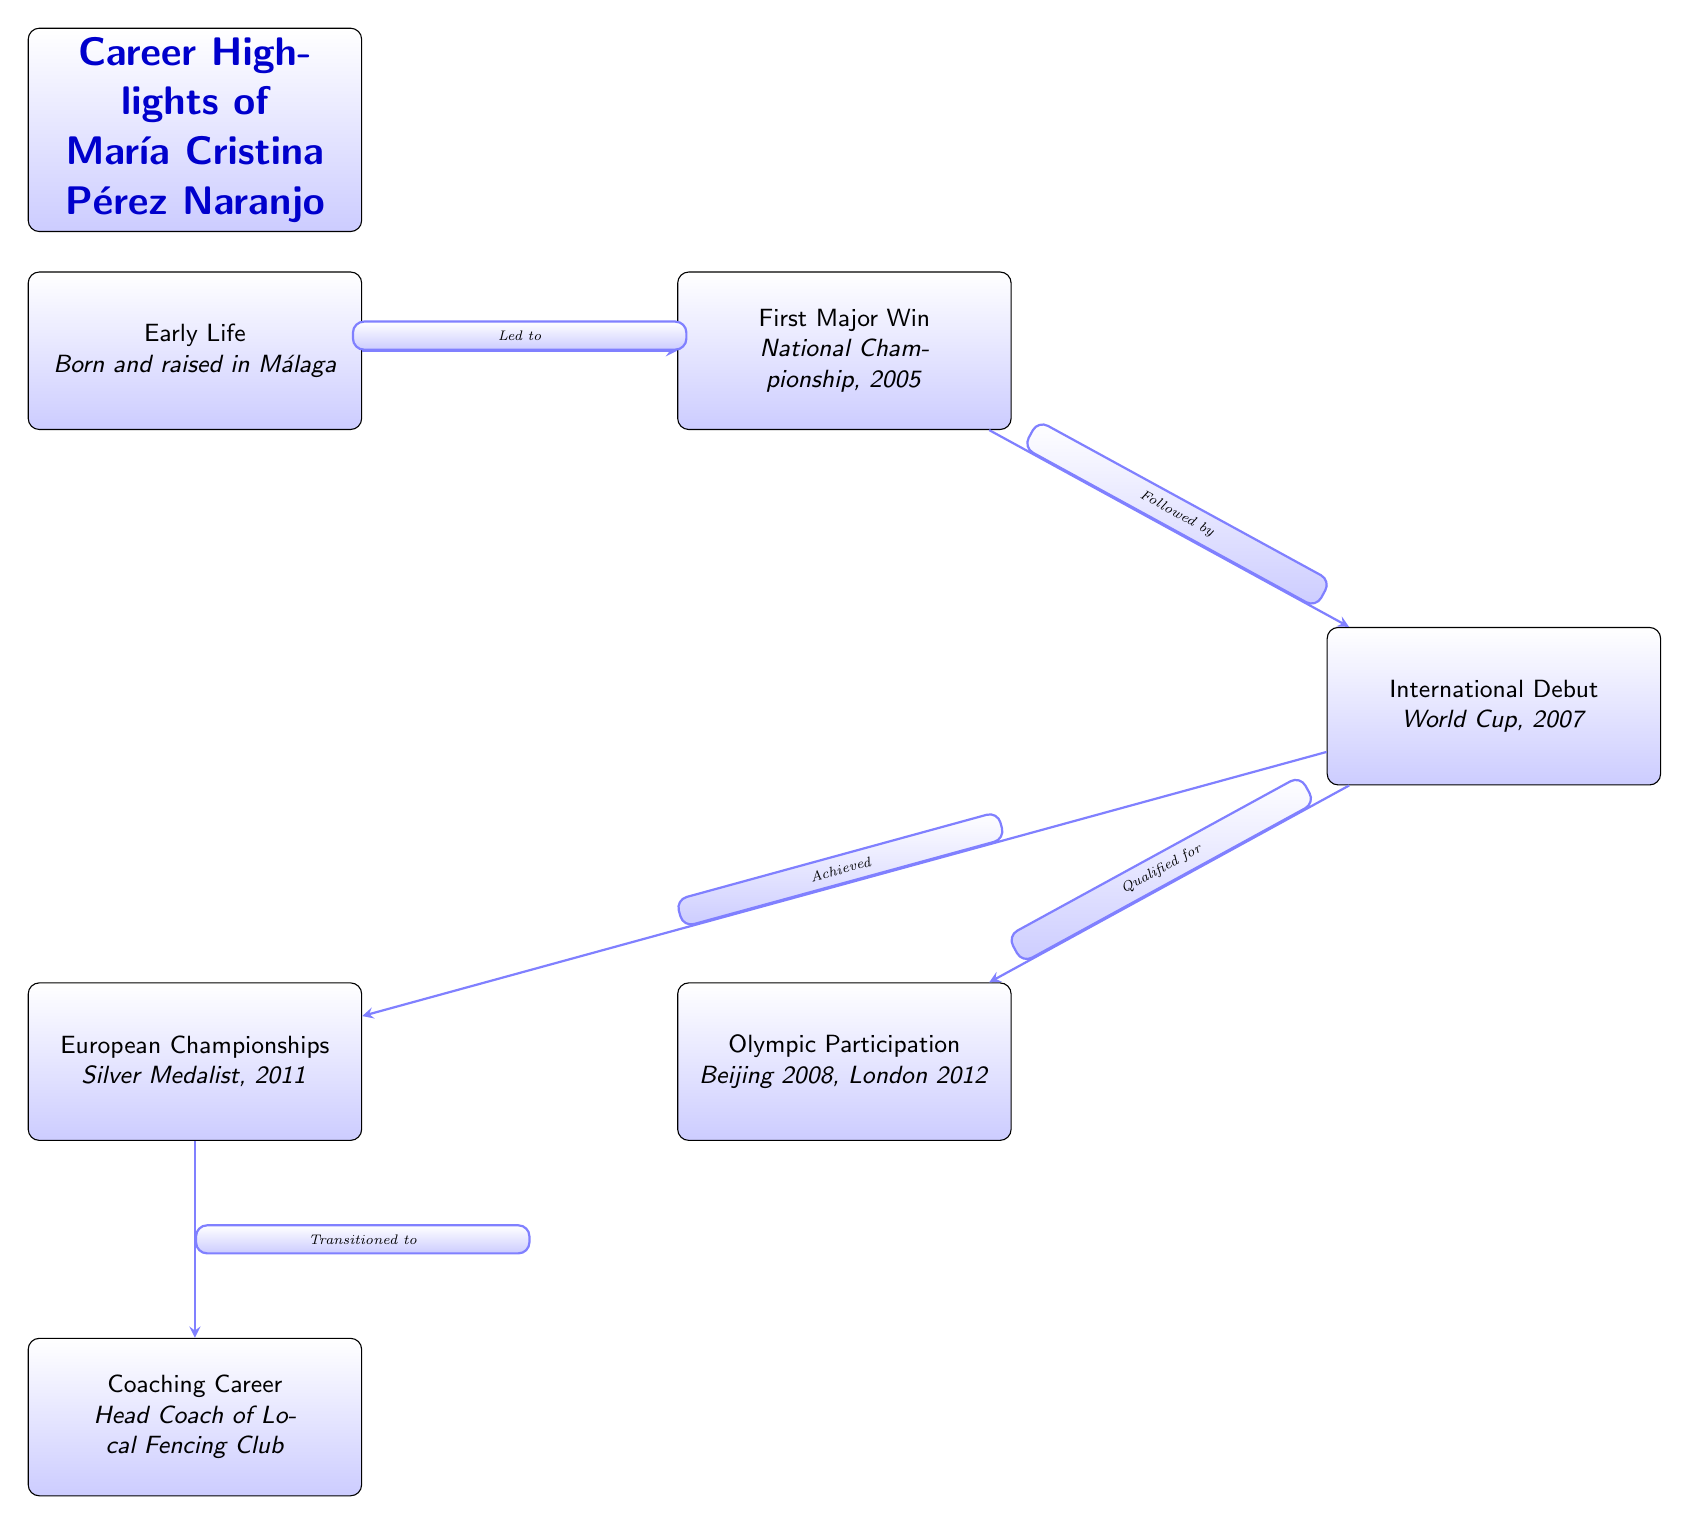What significant achievement occurred in 2005? The first major win highlighted in the diagram is the National Championship, which took place in 2005. This is directly indicated as the first event following the early life node.
Answer: National Championship, 2005 Who is the head coach of the Local Fencing Club? The coaching career of María Cristina Pérez Naranjo is described in the last node of the diagram, indicating that she transitioned to become the head coach of the local fencing club after her competitive career.
Answer: Head Coach of Local Fencing Club What event marked her international debut? The diagram highlights her international debut at the World Cup in 2007, shown as the third node after her first major win.
Answer: World Cup, 2007 How many Olympic participations did she have? The diagram mentions that María Cristina Pérez Naranjo participated in two Olympic Games: Beijing 2008 and London 2012. The nodes show both events connected to the international debut.
Answer: 2 What medal did she achieve in the European Championships? The diagram states that she earned a silver medal at the European Championships in 2011, positioned close to her Olympic participation events.
Answer: Silver Medal Which event preceded the European Championships? Looking at the diagram, the event that directly precedes the European Championships is her international debut at the World Cup in 2007, as indicated by the arrows connecting the nodes.
Answer: International Debut What does the arrow labeled "Led to" signify? The arrow labeled "Led to" connects the early life node to her first major win, indicating that her background was a precursor to this achievement in 2005.
Answer: First Major Win 